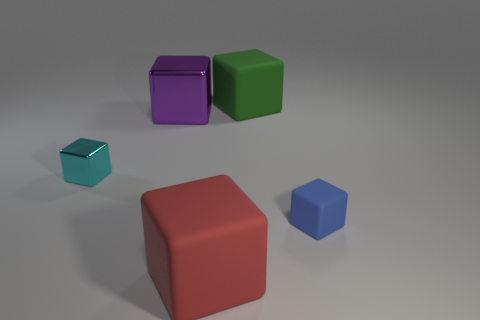Are there any other big green objects that have the same shape as the big metal object?
Your response must be concise. Yes. What number of things are cubes on the left side of the big red thing or purple cubes?
Your response must be concise. 2. Is the number of large purple blocks greater than the number of big yellow blocks?
Offer a terse response. Yes. Are there any green things of the same size as the green block?
Provide a succinct answer. No. How many objects are either rubber cubes that are right of the big green cube or blocks behind the blue matte cube?
Offer a very short reply. 4. What color is the object that is in front of the tiny cube that is in front of the cyan cube?
Ensure brevity in your answer.  Red. There is a tiny object that is made of the same material as the big green thing; what is its color?
Offer a very short reply. Blue. What number of things are cubes or big red matte objects?
Your answer should be very brief. 5. There is a green thing that is the same size as the purple shiny cube; what is its shape?
Your answer should be compact. Cube. What number of small objects are both right of the big red rubber thing and left of the blue block?
Provide a short and direct response. 0. 